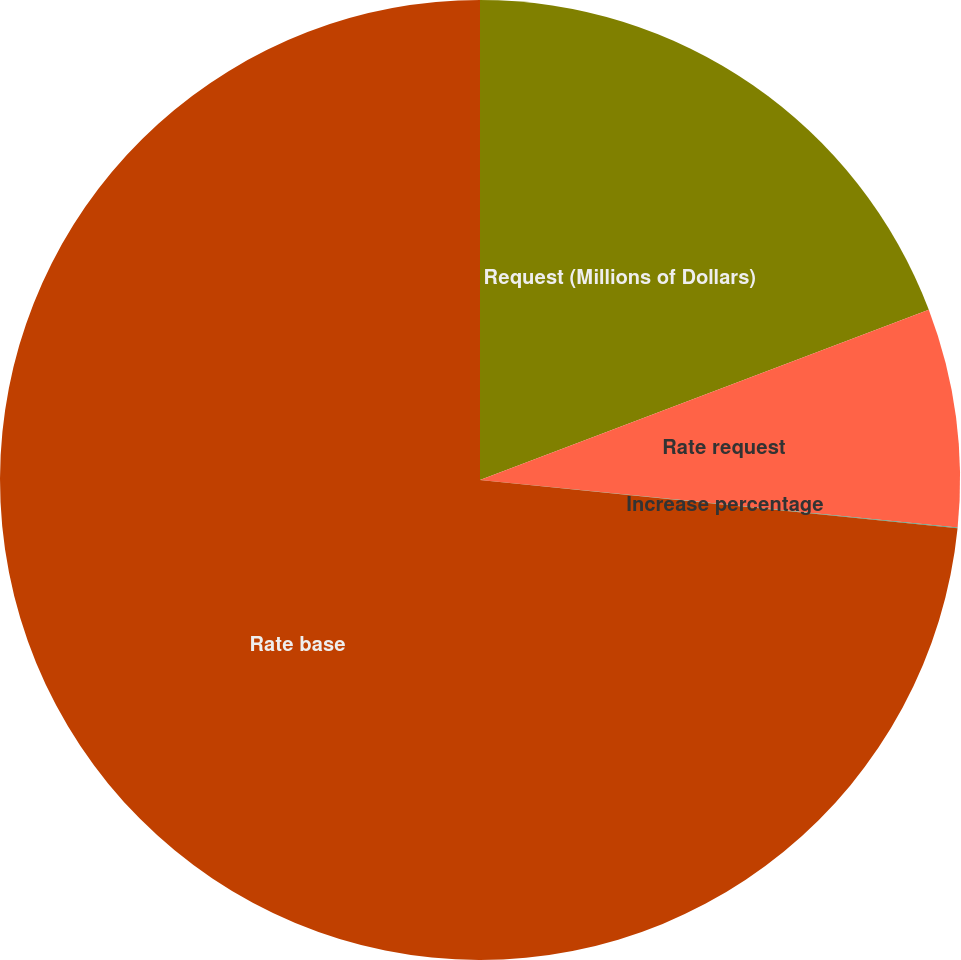Convert chart. <chart><loc_0><loc_0><loc_500><loc_500><pie_chart><fcel>Request (Millions of Dollars)<fcel>Rate request<fcel>Increase percentage<fcel>Rate base<nl><fcel>19.23%<fcel>7.35%<fcel>0.02%<fcel>73.4%<nl></chart> 